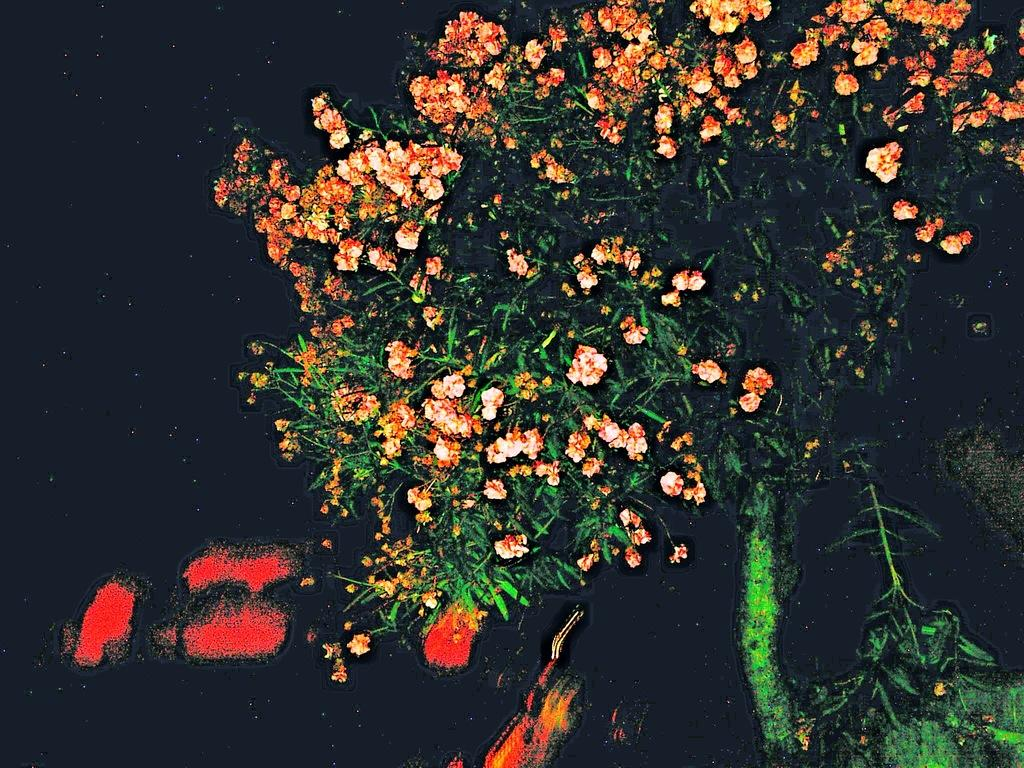What is the main subject of the image? The main subject of the image is a painting. What elements are included in the painting? The painting contains a tree and flowers. How would you describe the background of the painting? The background of the painting is dark. How many mittens can be seen hanging on the tree in the painting? There are no mittens present in the painting. 